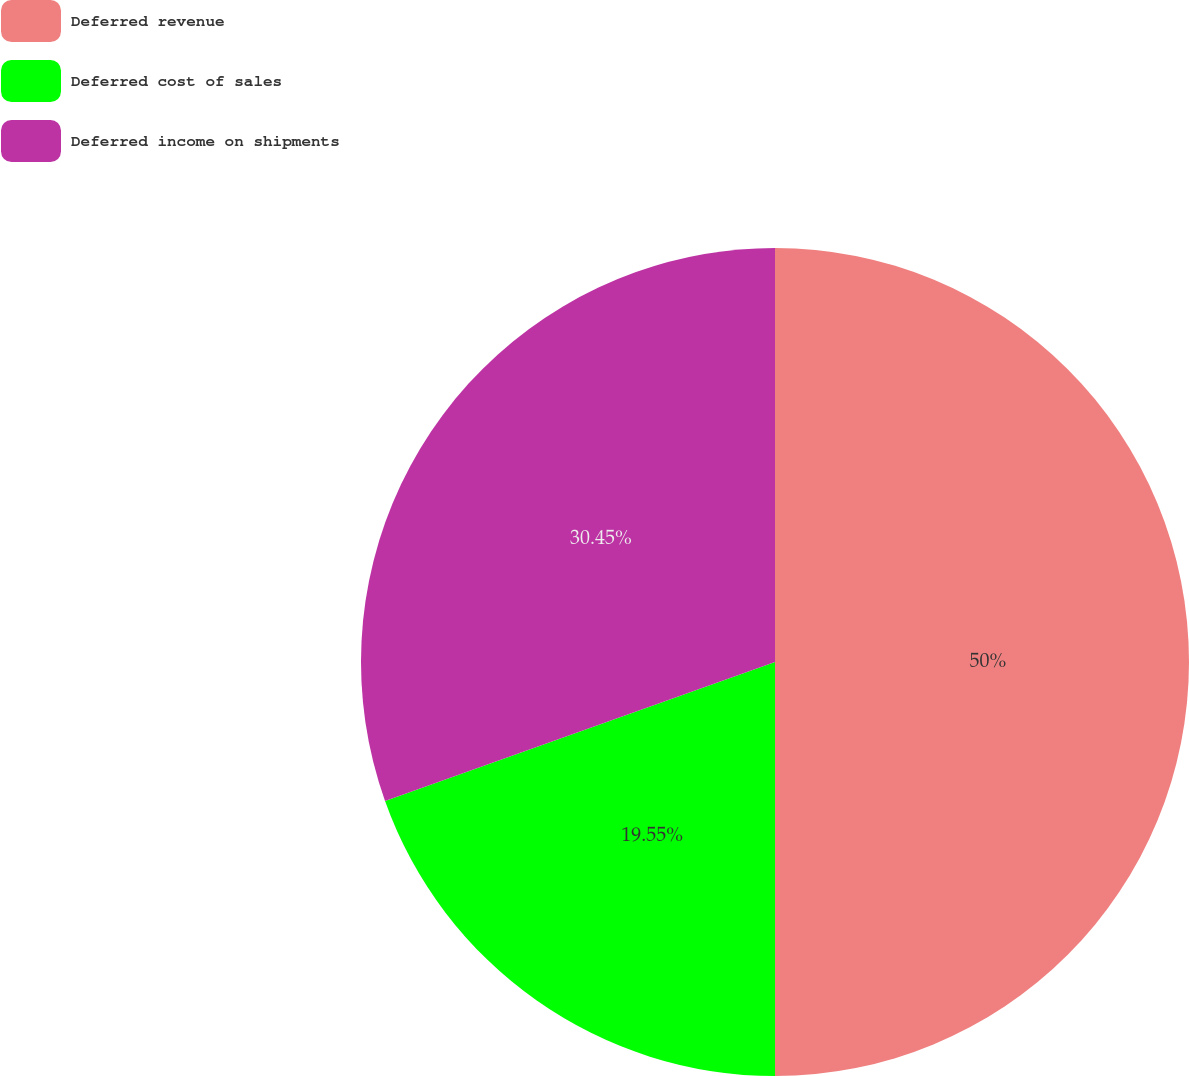Convert chart to OTSL. <chart><loc_0><loc_0><loc_500><loc_500><pie_chart><fcel>Deferred revenue<fcel>Deferred cost of sales<fcel>Deferred income on shipments<nl><fcel>50.0%<fcel>19.55%<fcel>30.45%<nl></chart> 